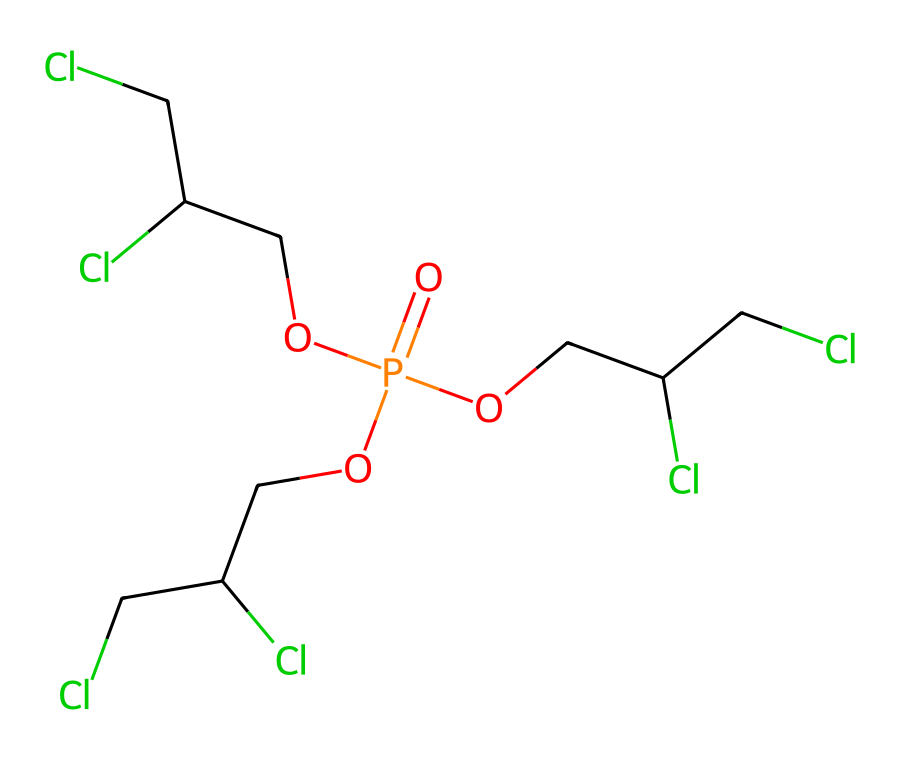What is the main functional group present in this chemical? The structure contains phosphorus (P) with a double bond to oxygen (O) and several alkoxy groups (OCC(CCl)Cl), indicating the presence of phosphate esters. Phosphates are known for their flame retardant properties.
Answer: phosphate How many chlorine atoms are present in this chemical? By examining the structure, each alkoxy group contains one chlorine atom and there are three identical alkoxy groups, totaling three chlorine atoms in the molecule.
Answer: three What is the total number of oxygen atoms in this chemical? The chemical structure shows one phosphorus atom with three alkoxy groups, each containing one oxygen atom, plus an additional oxygen bonded to phosphorus. This totals four oxygen atoms.
Answer: four Does this chemical have an acidic or basic character? The presence of phosphate and alkoxy groups suggests that this chemical can donate protons, yet typically phosphates have weak acidic character in solution. Therefore, it may behave as weakly acidic.
Answer: weakly acidic What type of bonding primarily characterizes the interactions in this molecule? The molecule showcases covalent bonding between the phosphorus, oxygen, and carbon atoms, as well as within the alkoxy groups where C-O and H-C bonds are present.
Answer: covalent bonding 